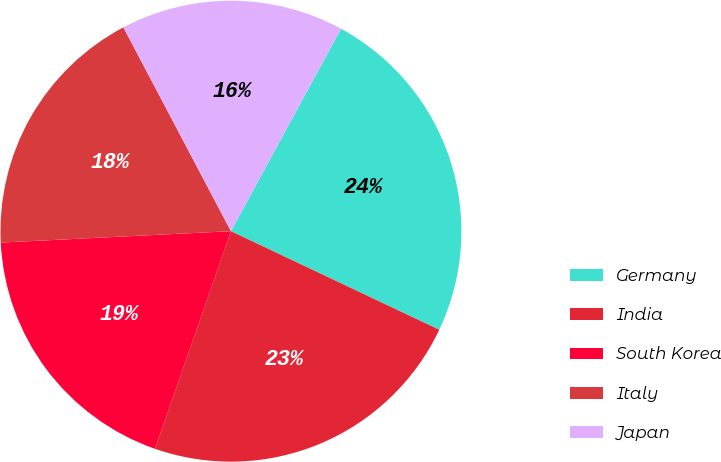<chart> <loc_0><loc_0><loc_500><loc_500><pie_chart><fcel>Germany<fcel>India<fcel>South Korea<fcel>Italy<fcel>Japan<nl><fcel>24.11%<fcel>23.31%<fcel>18.87%<fcel>18.06%<fcel>15.65%<nl></chart> 